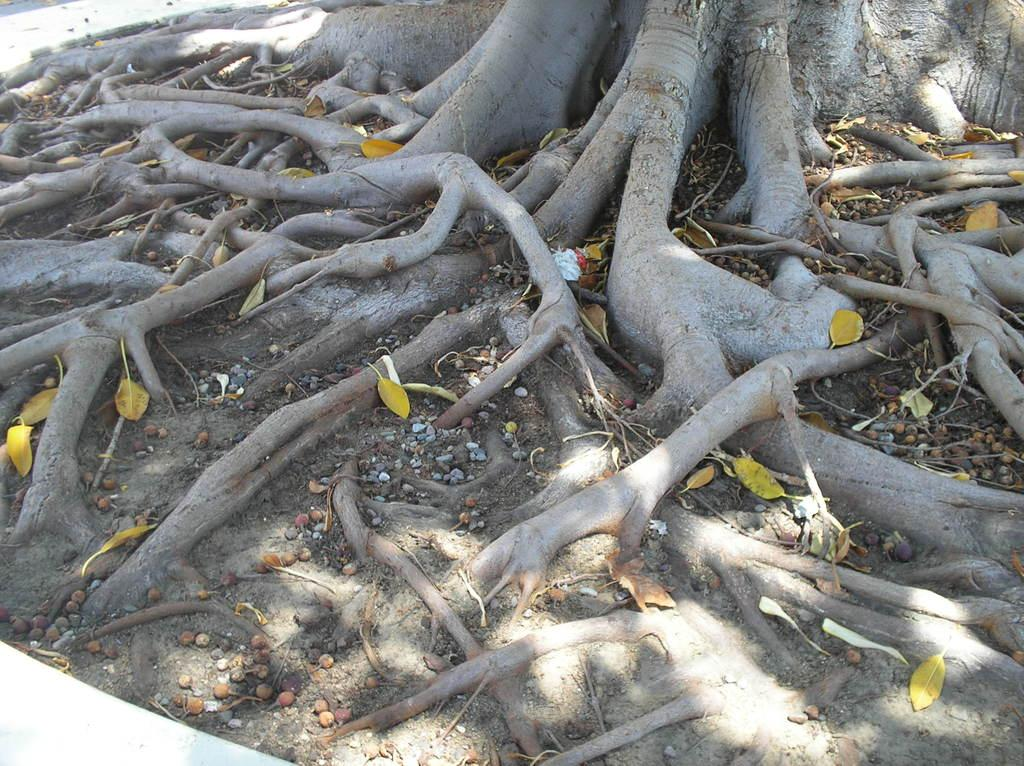What is the main subject of the image? The main subject of the image is the roots of a tree. Can you describe the appearance of the tree roots? The tree roots appear to be numerous and intertwined in the image. What type of polish is being applied to the pencil in the image? There is no pencil or polish present in the image; it only features the roots of a tree. 